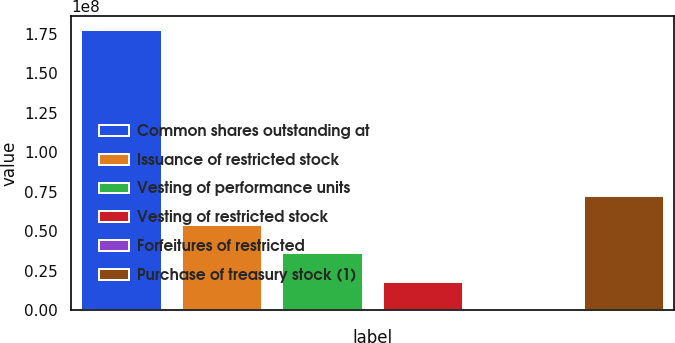Convert chart to OTSL. <chart><loc_0><loc_0><loc_500><loc_500><bar_chart><fcel>Common shares outstanding at<fcel>Issuance of restricted stock<fcel>Vesting of performance units<fcel>Vesting of restricted stock<fcel>Forfeitures of restricted<fcel>Purchase of treasury stock (1)<nl><fcel>1.77345e+08<fcel>5.40821e+07<fcel>3.60603e+07<fcel>1.80386e+07<fcel>16795<fcel>7.21038e+07<nl></chart> 